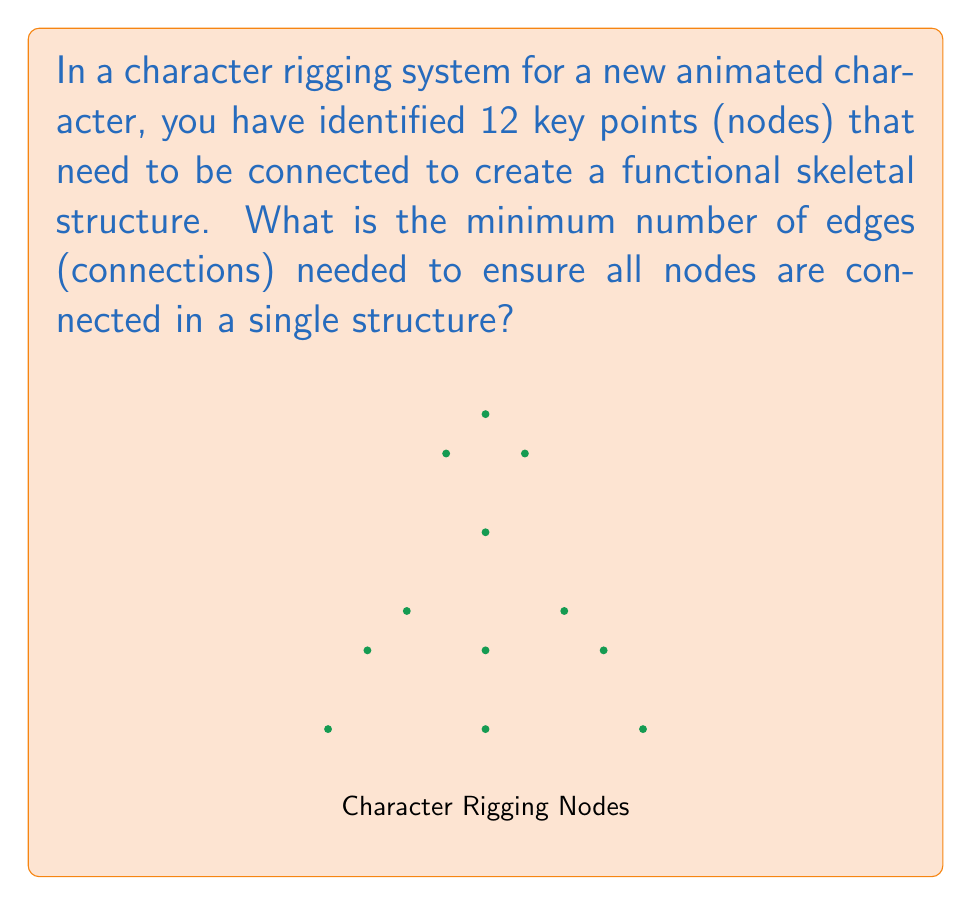Solve this math problem. To solve this problem, we need to understand the concept of a minimum spanning tree in graph theory. In a character rigging system, we want to connect all nodes with the minimum number of edges while ensuring that all nodes are reachable.

Step 1: Identify the properties of the problem
- We have 12 nodes (key points in the character rig)
- We need to connect all nodes
- We want the minimum number of connections

Step 2: Apply the formula for minimum spanning tree
In graph theory, the minimum number of edges needed to connect $n$ nodes in a single structure is given by the formula:

$$ \text{Minimum number of edges} = n - 1 $$

Where $n$ is the number of nodes.

Step 3: Calculate the result
Given that we have 12 nodes:

$$ \text{Minimum number of edges} = 12 - 1 = 11 $$

This result ensures that all 12 nodes are connected in a tree-like structure without any cycles, which is optimal for a character rigging system as it provides the necessary connections without redundancy.

Step 4: Verify the solution
With 11 edges connecting 12 nodes:
- Each node is reachable from any other node
- There are no cycles or redundant connections
- Adding any more edges would create unnecessary loops
- Removing any edge would disconnect the structure

Therefore, 11 edges represent the minimum number needed to connect all 12 nodes in the character rigging system.
Answer: 11 edges 